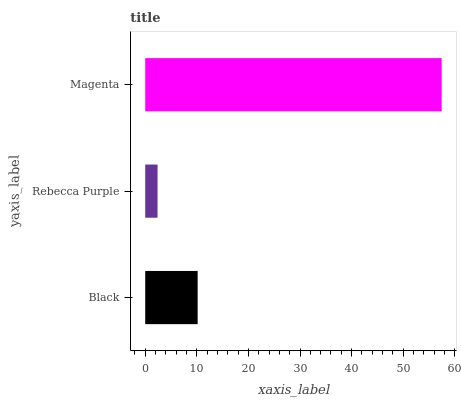Is Rebecca Purple the minimum?
Answer yes or no. Yes. Is Magenta the maximum?
Answer yes or no. Yes. Is Magenta the minimum?
Answer yes or no. No. Is Rebecca Purple the maximum?
Answer yes or no. No. Is Magenta greater than Rebecca Purple?
Answer yes or no. Yes. Is Rebecca Purple less than Magenta?
Answer yes or no. Yes. Is Rebecca Purple greater than Magenta?
Answer yes or no. No. Is Magenta less than Rebecca Purple?
Answer yes or no. No. Is Black the high median?
Answer yes or no. Yes. Is Black the low median?
Answer yes or no. Yes. Is Rebecca Purple the high median?
Answer yes or no. No. Is Rebecca Purple the low median?
Answer yes or no. No. 